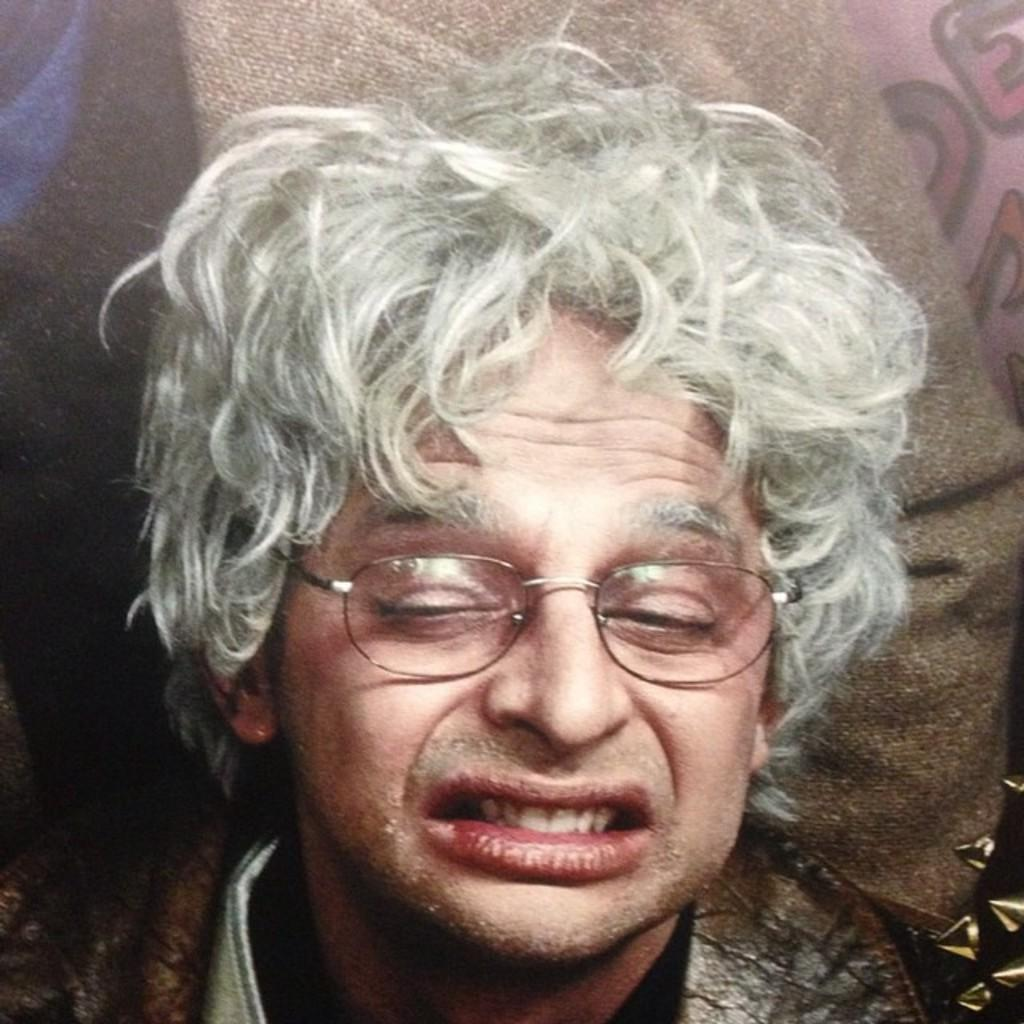Who is present in the image? There is a man in the picture. What is the man wearing on his face? The man is wearing spectacles. What type of clothing is the man wearing on his upper body? The man is wearing a jacket and a t-shirt. Where is the man sitting in the image? The man is sitting on a couch. What can be seen in the background of the image? There is a cloth visible in the background. What type of whip is the man holding in the image? There is no whip present in the image; the man is not holding any object. What is the man using to cover the couch in the image? The man is not using any coat or covering to protect the couch in the image. 